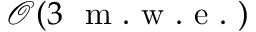<formula> <loc_0><loc_0><loc_500><loc_500>\mathcal { O } ( 3 m . w . e . )</formula> 